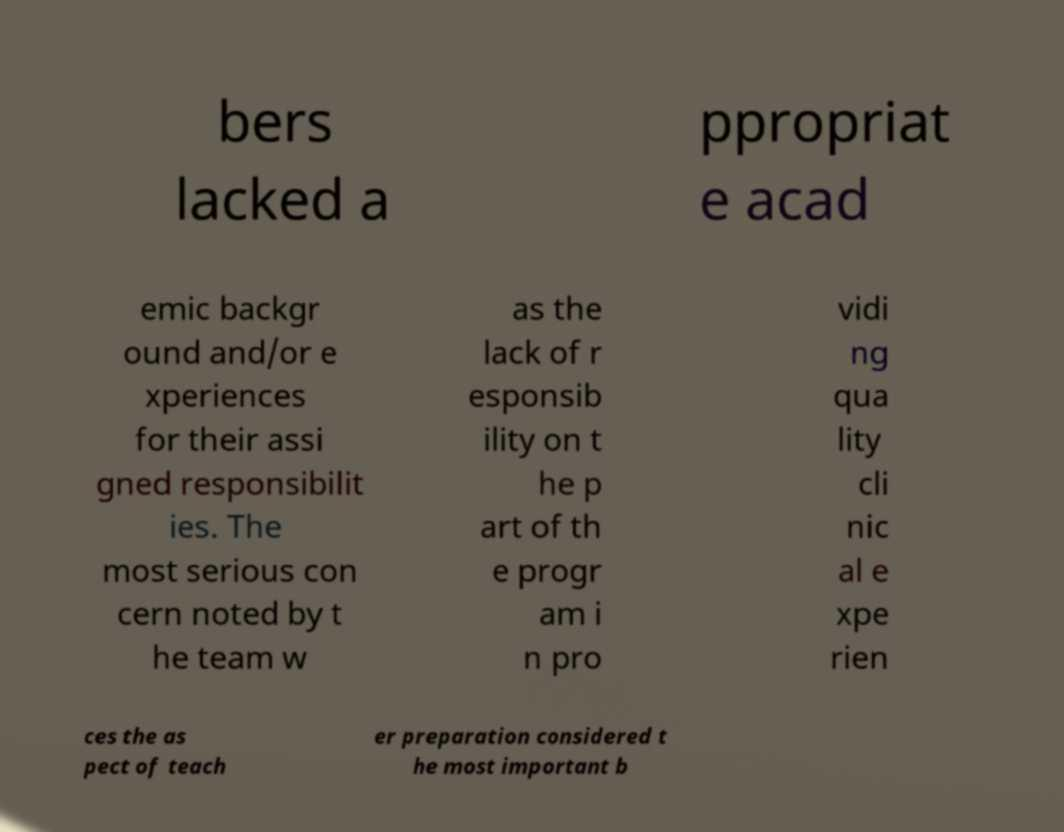I need the written content from this picture converted into text. Can you do that? bers lacked a ppropriat e acad emic backgr ound and/or e xperiences for their assi gned responsibilit ies. The most serious con cern noted by t he team w as the lack of r esponsib ility on t he p art of th e progr am i n pro vidi ng qua lity cli nic al e xpe rien ces the as pect of teach er preparation considered t he most important b 